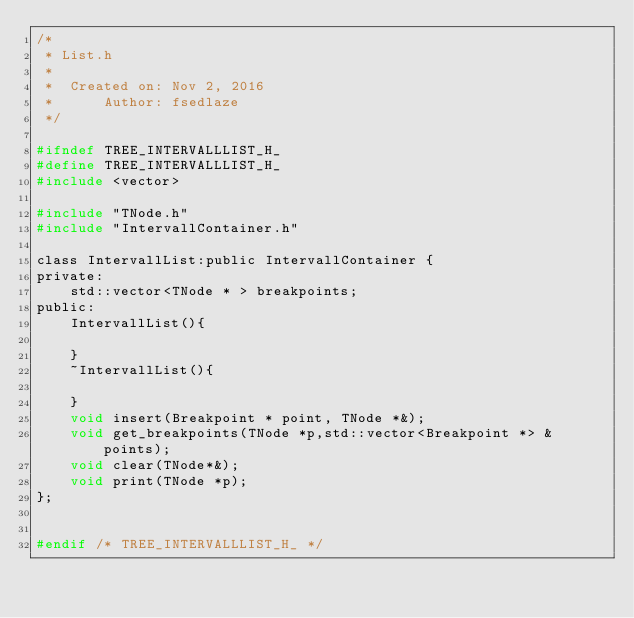<code> <loc_0><loc_0><loc_500><loc_500><_C_>/*
 * List.h
 *
 *  Created on: Nov 2, 2016
 *      Author: fsedlaze
 */

#ifndef TREE_INTERVALLLIST_H_
#define TREE_INTERVALLLIST_H_
#include <vector>

#include "TNode.h"
#include "IntervallContainer.h"

class IntervallList:public IntervallContainer {
private:
	std::vector<TNode * > breakpoints;
public:
	IntervallList(){

	}
	~IntervallList(){

	}
	void insert(Breakpoint * point, TNode *&);
	void get_breakpoints(TNode *p,std::vector<Breakpoint *> & points);
	void clear(TNode*&);
	void print(TNode *p);
};


#endif /* TREE_INTERVALLLIST_H_ */
</code> 